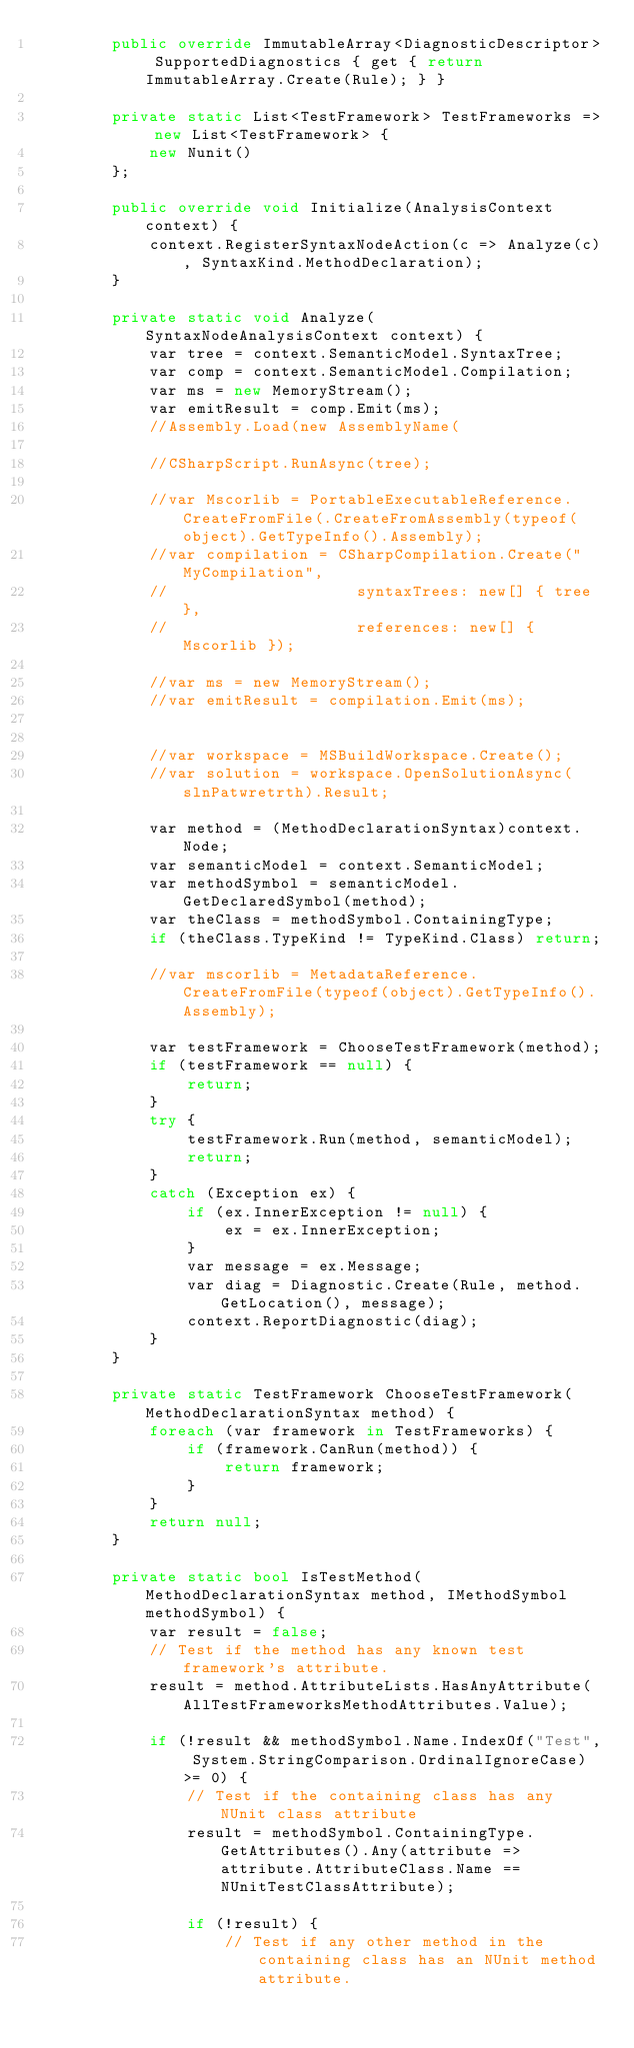Convert code to text. <code><loc_0><loc_0><loc_500><loc_500><_C#_>        public override ImmutableArray<DiagnosticDescriptor> SupportedDiagnostics { get { return ImmutableArray.Create(Rule); } }

        private static List<TestFramework> TestFrameworks => new List<TestFramework> {
            new Nunit()
        };

        public override void Initialize(AnalysisContext context) {
            context.RegisterSyntaxNodeAction(c => Analyze(c), SyntaxKind.MethodDeclaration);
        }

        private static void Analyze(SyntaxNodeAnalysisContext context) {
            var tree = context.SemanticModel.SyntaxTree;
            var comp = context.SemanticModel.Compilation;
            var ms = new MemoryStream();
            var emitResult = comp.Emit(ms);
            //Assembly.Load(new AssemblyName(

            //CSharpScript.RunAsync(tree);

            //var Mscorlib = PortableExecutableReference.CreateFromFile(.CreateFromAssembly(typeof(object).GetTypeInfo().Assembly);
            //var compilation = CSharpCompilation.Create("MyCompilation",
            //                    syntaxTrees: new[] { tree }, 
            //                    references: new[] { Mscorlib });

            //var ms = new MemoryStream();
            //var emitResult = compilation.Emit(ms);


            //var workspace = MSBuildWorkspace.Create();
            //var solution = workspace.OpenSolutionAsync(slnPatwretrth).Result;

            var method = (MethodDeclarationSyntax)context.Node;
            var semanticModel = context.SemanticModel;
            var methodSymbol = semanticModel.GetDeclaredSymbol(method);
            var theClass = methodSymbol.ContainingType;
            if (theClass.TypeKind != TypeKind.Class) return;

            //var mscorlib = MetadataReference.CreateFromFile(typeof(object).GetTypeInfo().Assembly);
            
            var testFramework = ChooseTestFramework(method);
            if (testFramework == null) {
                return;
            }
            try {
                testFramework.Run(method, semanticModel);
                return;
            }
            catch (Exception ex) {
                if (ex.InnerException != null) {
                    ex = ex.InnerException;
                }
                var message = ex.Message;
                var diag = Diagnostic.Create(Rule, method.GetLocation(), message);
                context.ReportDiagnostic(diag);
            }
        }

        private static TestFramework ChooseTestFramework(MethodDeclarationSyntax method) {
            foreach (var framework in TestFrameworks) {
                if (framework.CanRun(method)) {
                    return framework;
                }
            }
            return null;
        }

        private static bool IsTestMethod(MethodDeclarationSyntax method, IMethodSymbol methodSymbol) {
            var result = false;
            // Test if the method has any known test framework's attribute.
            result = method.AttributeLists.HasAnyAttribute(AllTestFrameworksMethodAttributes.Value);

            if (!result && methodSymbol.Name.IndexOf("Test", System.StringComparison.OrdinalIgnoreCase) >= 0) {
                // Test if the containing class has any NUnit class attribute
                result = methodSymbol.ContainingType.GetAttributes().Any(attribute => attribute.AttributeClass.Name == NUnitTestClassAttribute);

                if (!result) {
                    // Test if any other method in the containing class has an NUnit method attribute.</code> 